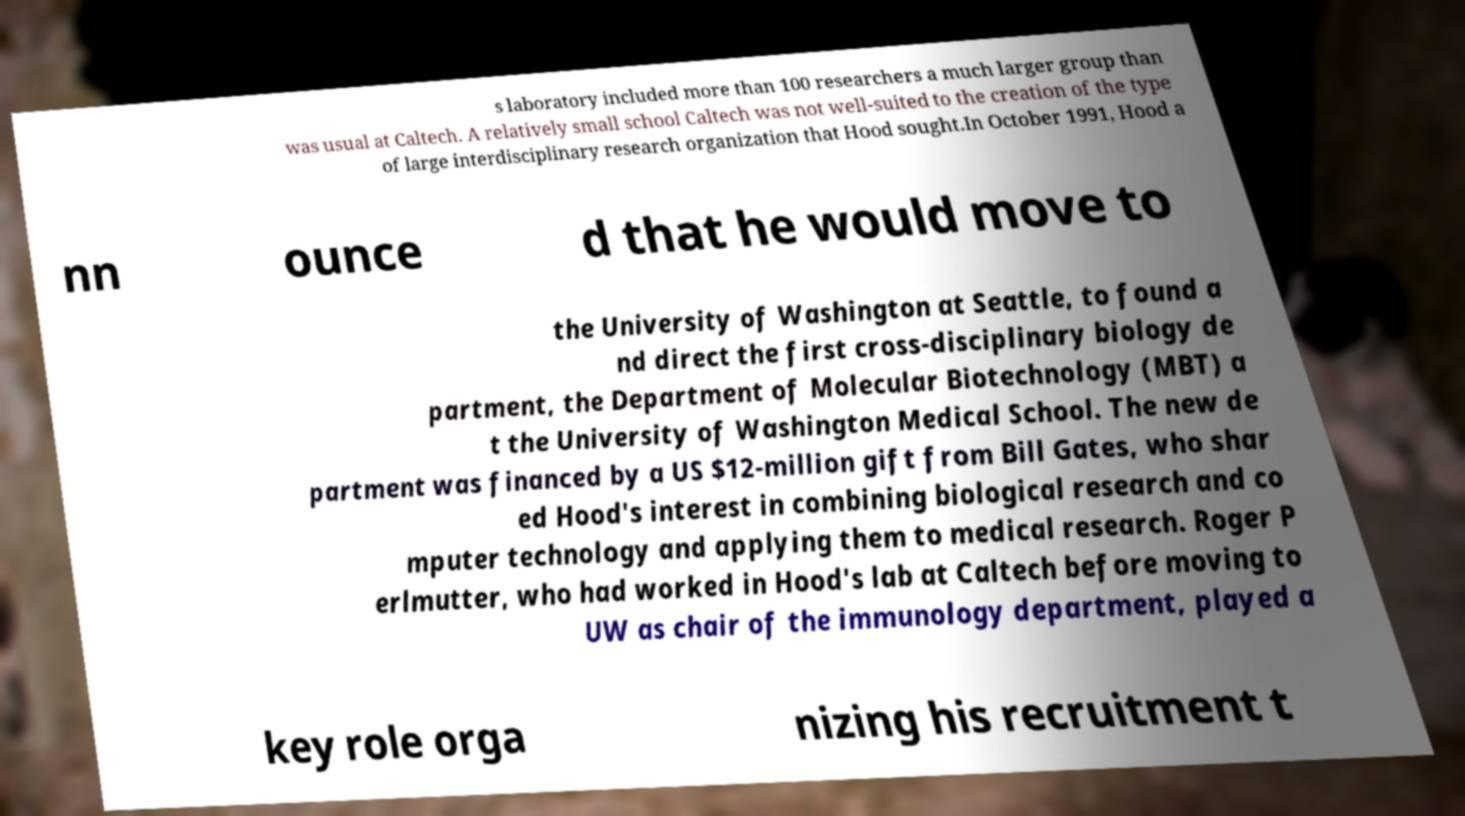Can you read and provide the text displayed in the image?This photo seems to have some interesting text. Can you extract and type it out for me? s laboratory included more than 100 researchers a much larger group than was usual at Caltech. A relatively small school Caltech was not well-suited to the creation of the type of large interdisciplinary research organization that Hood sought.In October 1991, Hood a nn ounce d that he would move to the University of Washington at Seattle, to found a nd direct the first cross-disciplinary biology de partment, the Department of Molecular Biotechnology (MBT) a t the University of Washington Medical School. The new de partment was financed by a US $12-million gift from Bill Gates, who shar ed Hood's interest in combining biological research and co mputer technology and applying them to medical research. Roger P erlmutter, who had worked in Hood's lab at Caltech before moving to UW as chair of the immunology department, played a key role orga nizing his recruitment t 